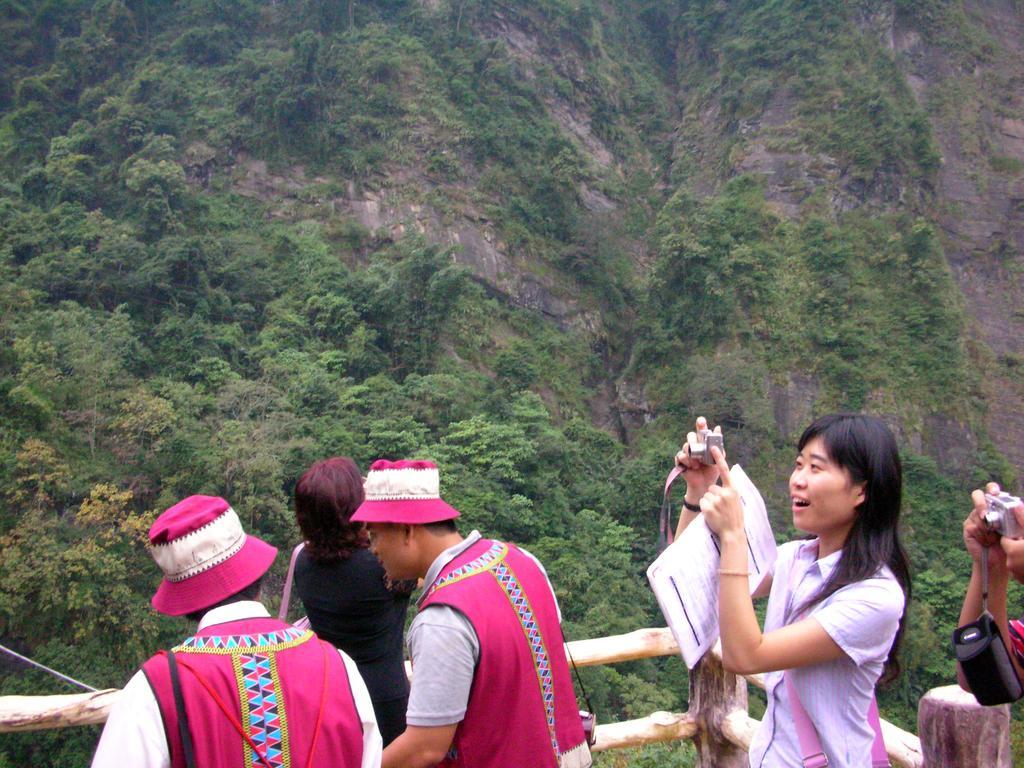Describe this image in one or two sentences. In front of the image there are a few people holding cameras. Behind them there is a wooden fence. In the background of the image there are trees and rocks. 